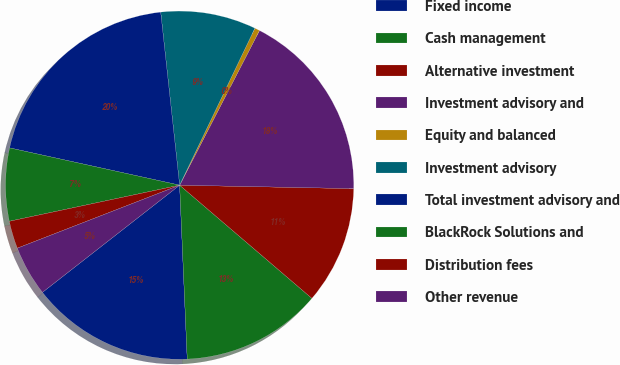<chart> <loc_0><loc_0><loc_500><loc_500><pie_chart><fcel>Fixed income<fcel>Cash management<fcel>Alternative investment<fcel>Investment advisory and<fcel>Equity and balanced<fcel>Investment advisory<fcel>Total investment advisory and<fcel>BlackRock Solutions and<fcel>Distribution fees<fcel>Other revenue<nl><fcel>15.14%<fcel>13.04%<fcel>10.95%<fcel>17.73%<fcel>0.47%<fcel>8.85%<fcel>19.83%<fcel>6.76%<fcel>2.57%<fcel>4.66%<nl></chart> 